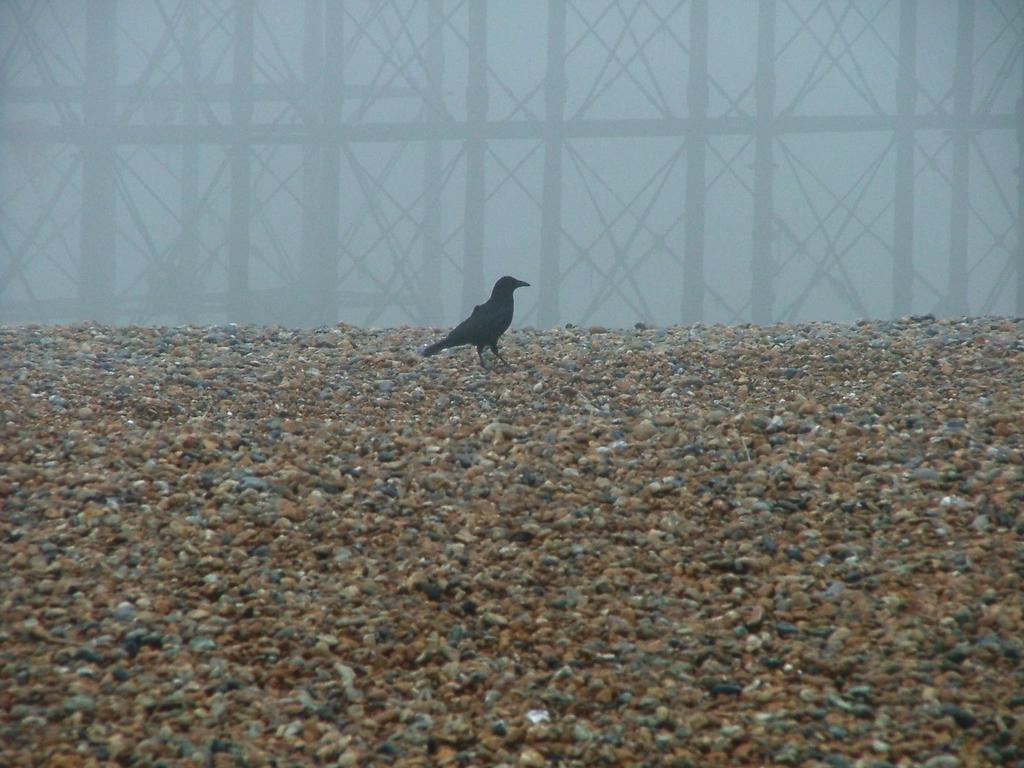Please provide a concise description of this image. In the image we can see a bird, sand and a pole. The bird is black in color. 